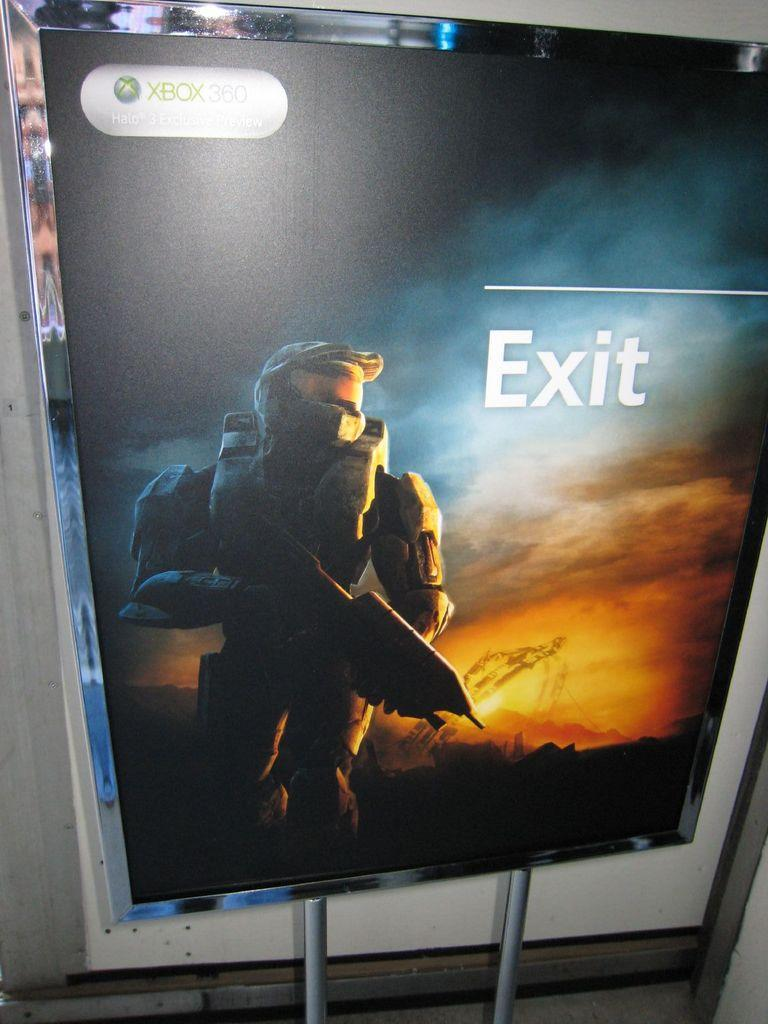<image>
Summarize the visual content of the image. a Halo character next to an exit logo 